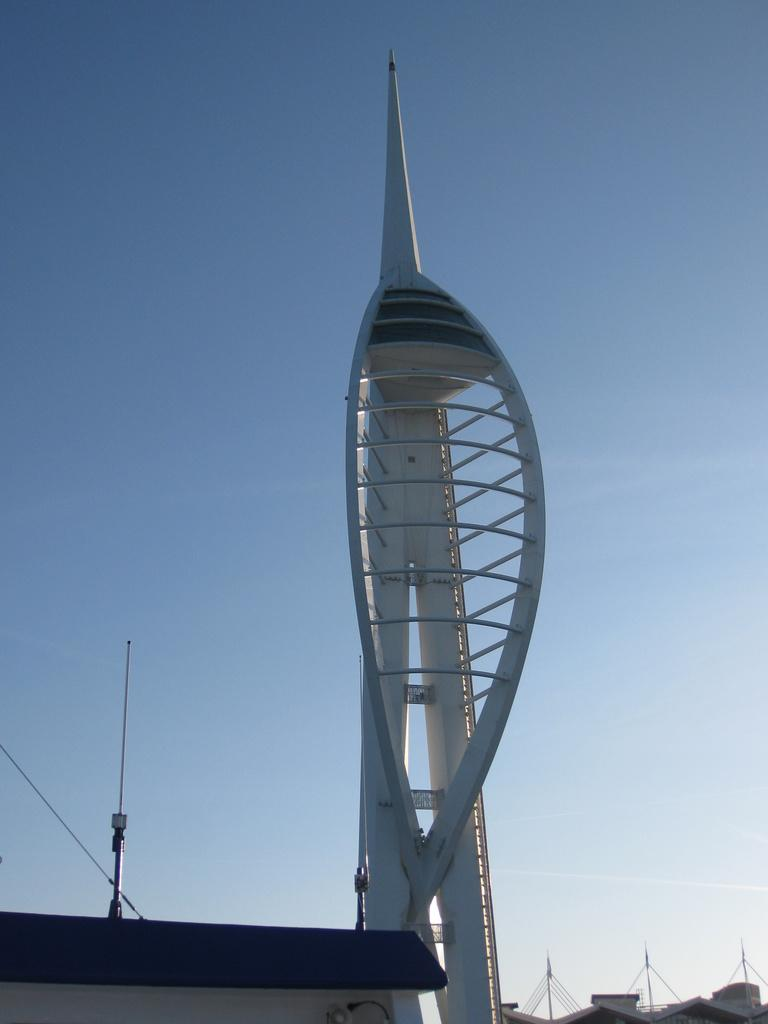What is the main structure in the image? There is a tall tower in the image. What else can be seen behind the tower? There are poles behind the tower. What can be seen in the background of the image? The sky is visible in the background of the image. How does the tower need to be tricked into standing up straight? The tower does not need to be tricked into standing up straight; it is already standing in the image. 